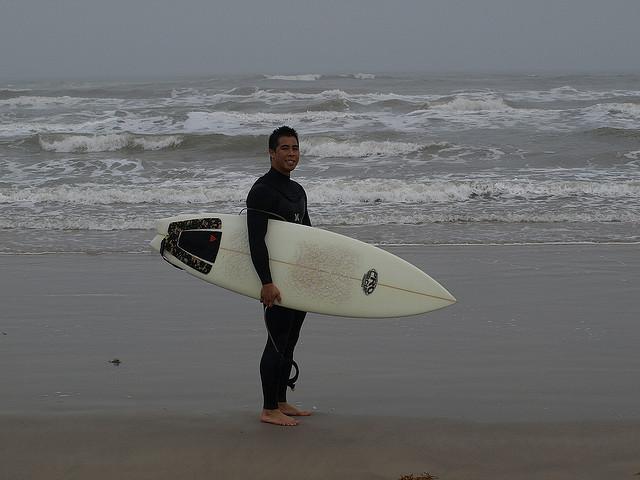Is the man wearing shoes?
Answer briefly. No. How many people are in the picture?
Quick response, please. 1. What is the man holding in his hand?
Concise answer only. Surfboard. Why are these people wearing wetsuits?
Write a very short answer. Surfing. How many surfers are shown?
Keep it brief. 1. What is the man holding?
Give a very brief answer. Surfboard. What is the man's hair color?
Write a very short answer. Black. Does the board have graffiti on it?
Concise answer only. No. Is the man wearing a hat?
Short answer required. No. What is the man getting ready to do?
Be succinct. Surf. 